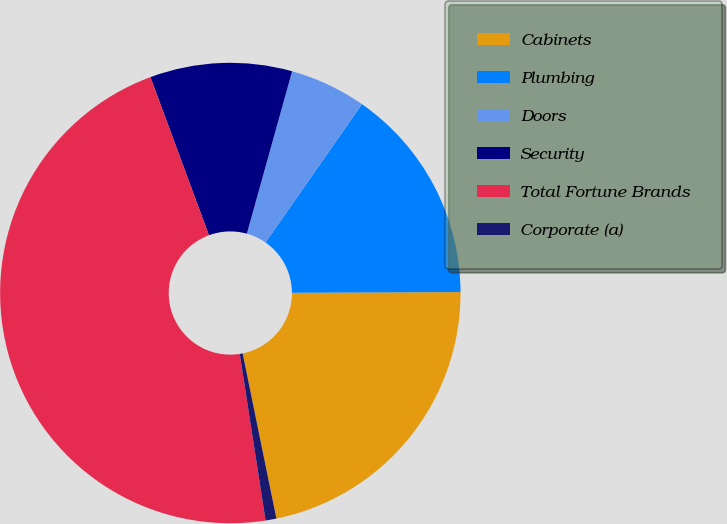<chart> <loc_0><loc_0><loc_500><loc_500><pie_chart><fcel>Cabinets<fcel>Plumbing<fcel>Doors<fcel>Security<fcel>Total Fortune Brands<fcel>Corporate (a)<nl><fcel>21.86%<fcel>15.25%<fcel>5.36%<fcel>9.97%<fcel>46.81%<fcel>0.76%<nl></chart> 